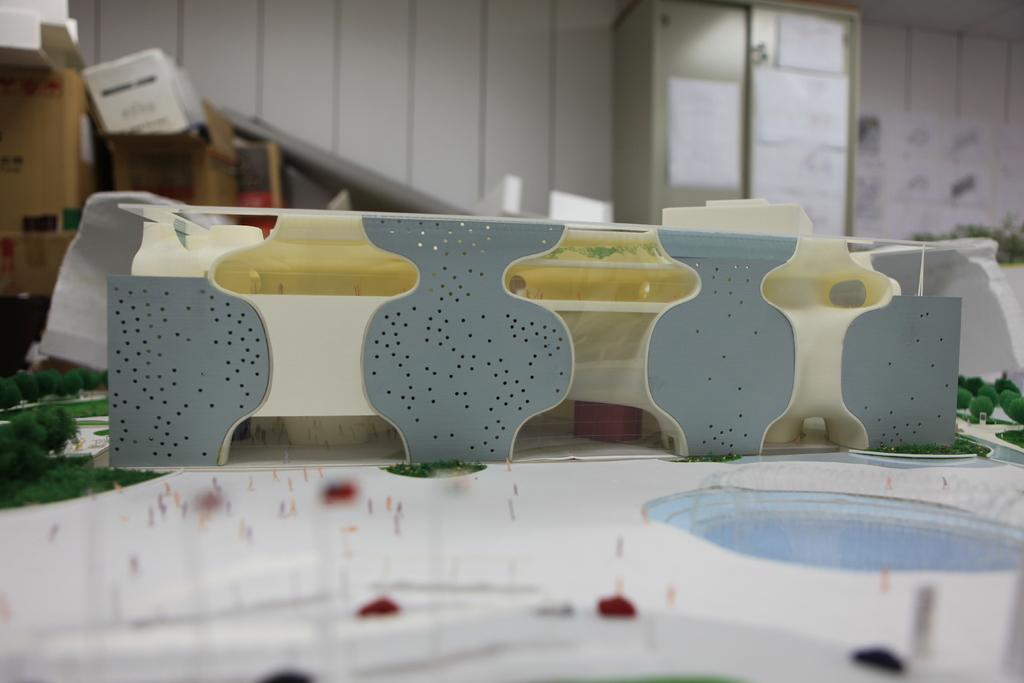What is the main subject of the image? The main subject of the image is a model of a flat. What feature is included in the model of the flat? The model includes a swimming pool. What type of vegetation can be seen in the image? There are trees in the image. What materials are visible in the background of the image? Cardboards and cupboards are present in the background of the image. What type of spring can be seen in the image? There is no spring present in the image; it features a model of a flat with a swimming pool, trees, and cardboards and cupboards in the background. Who is the representative of the building in the image? There is no representative present in the image; it is a model of a flat with no people depicted. 